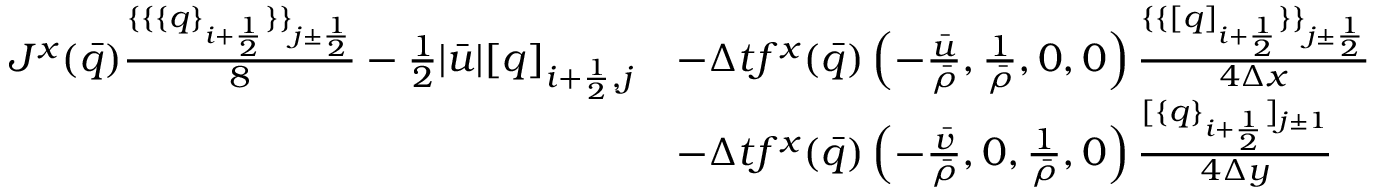<formula> <loc_0><loc_0><loc_500><loc_500>\begin{array} { r l } { J ^ { x } ( \bar { q } ) \frac { \{ \{ \{ q \} _ { i + \frac { 1 } { 2 } } \} \} _ { j \pm \frac { 1 } { 2 } } } { 8 } - \frac { 1 } { 2 } | \bar { u } | [ q ] _ { i + \frac { 1 } { 2 } , j } } & { - \Delta t f ^ { x } ( \bar { q } ) \left ( - \frac { \bar { u } } { \bar { \rho } } , \frac { 1 } { \bar { \rho } } , 0 , 0 \right ) \frac { \{ \{ [ q ] _ { i + \frac { 1 } { 2 } } \} \} _ { j \pm \frac { 1 } { 2 } } } { 4 \Delta x } } \\ & { - \Delta t f ^ { x } ( \bar { q } ) \left ( - \frac { \bar { v } } { \bar { \rho } } , 0 , \frac { 1 } { \bar { \rho } } , 0 \right ) \frac { [ \{ q \} _ { i + \frac { 1 } { 2 } } ] _ { j \pm 1 } } { 4 \Delta y } } \end{array}</formula> 